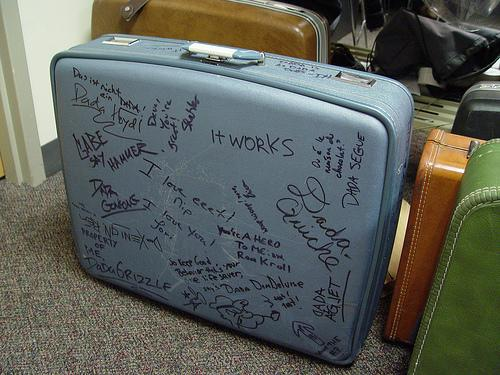Describe the condition of the carpet in the image. The carpet is gray and rough, with a possible thin blue carpet on the floor covering some areas. Describe the sentiments or feelings this image evokes. The image evokes a sense of travel, organization, and anticipation, as the suitcases are packed and ready to go. What type of bag is behind the suitcases and what color is it? There is a black nylon bag behind the suitcases. Which suitcases have straps or handles visible in the image? The blue suitcase with a white and blue handle, the brown suitcase with white stitching, and another brown suitcase with a brown strap hanging over it. What is the main color of the door frame in the image? The door frame is gray. What kind of writing can be seen on some suitcases in the image? There is black writing, black marker writing, black signatures, and writing all over the side of a blue suitcase. What can you infer about the owner of the suitcases and bags in the image? The owner of the suitcases and bags might be somebody who travels frequently or someone preparing for a trip, and they have a variety of luggage types and sizes to suit their needs. List all the objects you can find in the image. green suitcase, brown suitcase, black suitcase, blue suitcase, black writing, gray carpet, gray baseboards, brown suitcase behind blue suitcase, black bag, gray door frame, wall, white tag, black nylon bag, white wooden door frame, blue and white suitcase handle. What is unusual about the stitching on one of the brown suitcases? The suitcase has thick white stitching on the edge of the luggage. How many suitcases are there in the image? There are six suitcases in the image. Which object in the image appears to have the thickest white stitching on the edge? Luggage Describe the scene by mentioning at least 3 suitcases and their positions relative to each other. A green suitcase is sitting on the ground, a blue suitcase is next to a black bag, and a brown suitcase is behind the blue one. Is there a gray door frame present in the room? Yes Select the best description for the given image: A) A room with multiple chairs and tables. B) An outdoor setting with trees and a bike. C) Multiple suitcases with writings and distinguishable features are lying on the ground. C) Multiple suitcases with writings and distinguishable features are lying on the ground. Using the information provided, create a short piece of content describing the scene at the suitcases, mentioning at least two distinct features. On the ground, there is a line-up of various suitcases, showing signatures and writing. A blue and white-striped suitcase handle stands out from the rest, and a black nylon bag rests nearby. Understand the given graphic: describe the location of the gray carpet in relation to other objects in the room. The gray carpet is on the ground, covering the floor near the suitcases. Are there seven suitcases in a row on top of the gray carpet? The captions only mention multiple suitcases and a gray carpet, but there is no direct indication that there are seven suitcases in a row. Which suitcase would most likely belong to someone who likes to collect autographs? The suitcase with black writing on it Is the green suitcase on the floor adorned with red polka dots?  The existing captions only mention a green suitcase sitting on the ground but do not include any information regarding any red polka dots. Can you see a white cat sitting on the gray and white tweed floor rug? While there is a mention of a gray and white tweed floor rug, none of the captions describe a white cat sitting on it. Create a simple description of the scene, mentioning any indicators that the suitcases have unique features or designs. Various suitcases are lying on a gray carpet, some featuring writings or standout handles, showcasing a mix of colors and individuality. What type of bag can be found near the suitcases? Black nylon bag Is there a pink umbrella resting on the black nylon bag on the floor? The captions mention a black nylon bag on the floor, but there is no information about a pink umbrella resting on it. Identify the color of the writing present on a suitcase. Black Does the brown suitcase have a large purple sticker across its front side? While there is a brown suitcase mentioned, there is no information about a purple sticker on it in any of the captions. Identify the color of the strap hanging over a suitcase. Brown Can you detect any intricate patterns or designs on the gray and white tweed floor rug? No intricate patterns or designs Which of the following is true: A) There are four suitcases lying in a row. B) There are three suitcases stacked on top of each other. C) A dog is sitting on a gray carpet. A) There are four suitcases lying in a row. Can you locate the bright orange handbag right beside the blue suitcase? There is no mention of a bright orange handbag beside the blue suitcase in any of the captions. What color is the suitcase positioned at the top-left corner of the image? Blue Which color of the suitcase handle best matches the following description - "handle with alternating stripes of two colors"? Blue and white Detect the main event taking place in the image. Several suitcases are lined up on the ground. What type of activity is the most dominant focus in the image? Suitcases arranged/displayed 